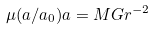<formula> <loc_0><loc_0><loc_500><loc_500>\mu ( a / a _ { 0 } ) a = M G r ^ { - 2 }</formula> 